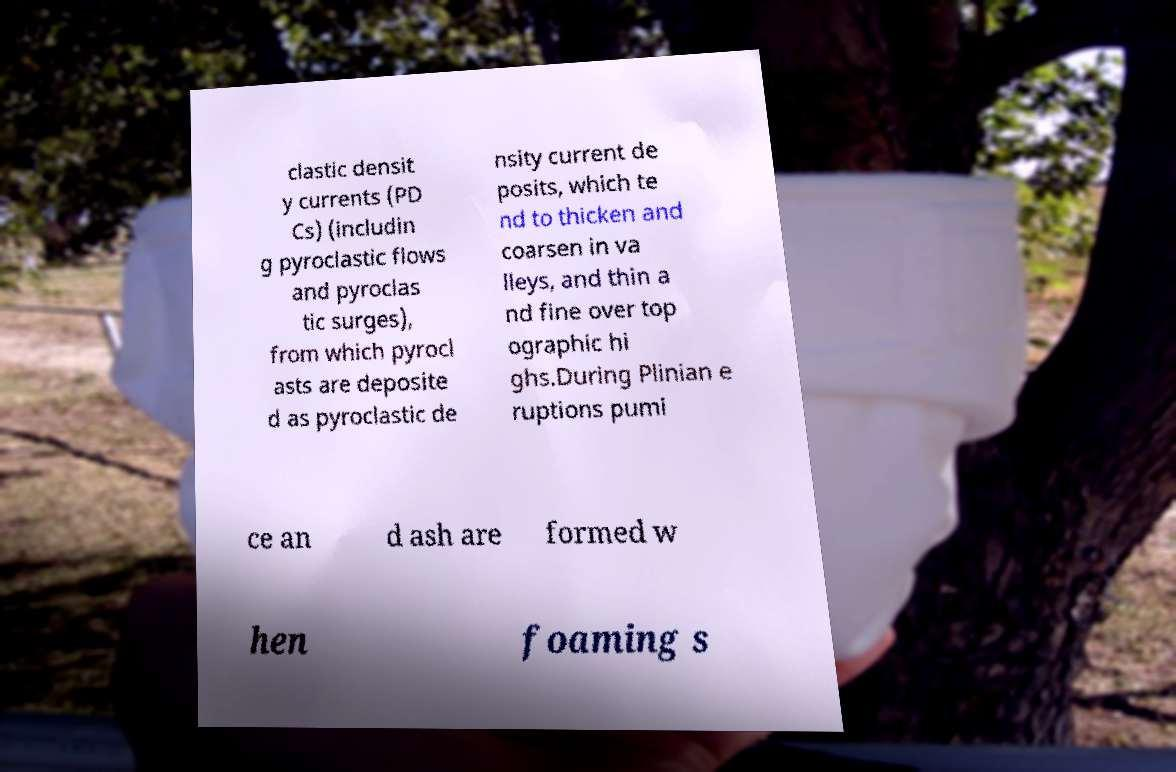I need the written content from this picture converted into text. Can you do that? clastic densit y currents (PD Cs) (includin g pyroclastic flows and pyroclas tic surges), from which pyrocl asts are deposite d as pyroclastic de nsity current de posits, which te nd to thicken and coarsen in va lleys, and thin a nd fine over top ographic hi ghs.During Plinian e ruptions pumi ce an d ash are formed w hen foaming s 